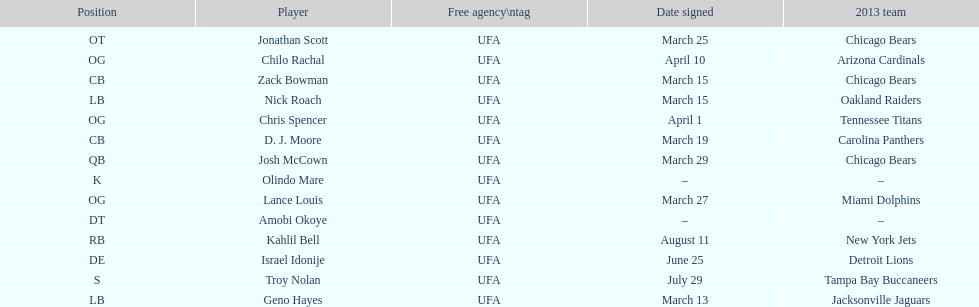How many players were recruited in march? 7. 